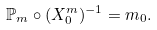<formula> <loc_0><loc_0><loc_500><loc_500>\mathbb { P } _ { m } \circ ( X ^ { m } _ { 0 } ) ^ { - 1 } = m _ { 0 } .</formula> 